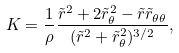Convert formula to latex. <formula><loc_0><loc_0><loc_500><loc_500>K = \frac { 1 } { \rho } \frac { \tilde { r } ^ { 2 } + 2 \tilde { r } _ { \theta } ^ { 2 } - \tilde { r } \tilde { r } _ { \theta \theta } } { ( \tilde { r } ^ { 2 } + \tilde { r } _ { \theta } ^ { 2 } ) ^ { 3 / 2 } } ,</formula> 